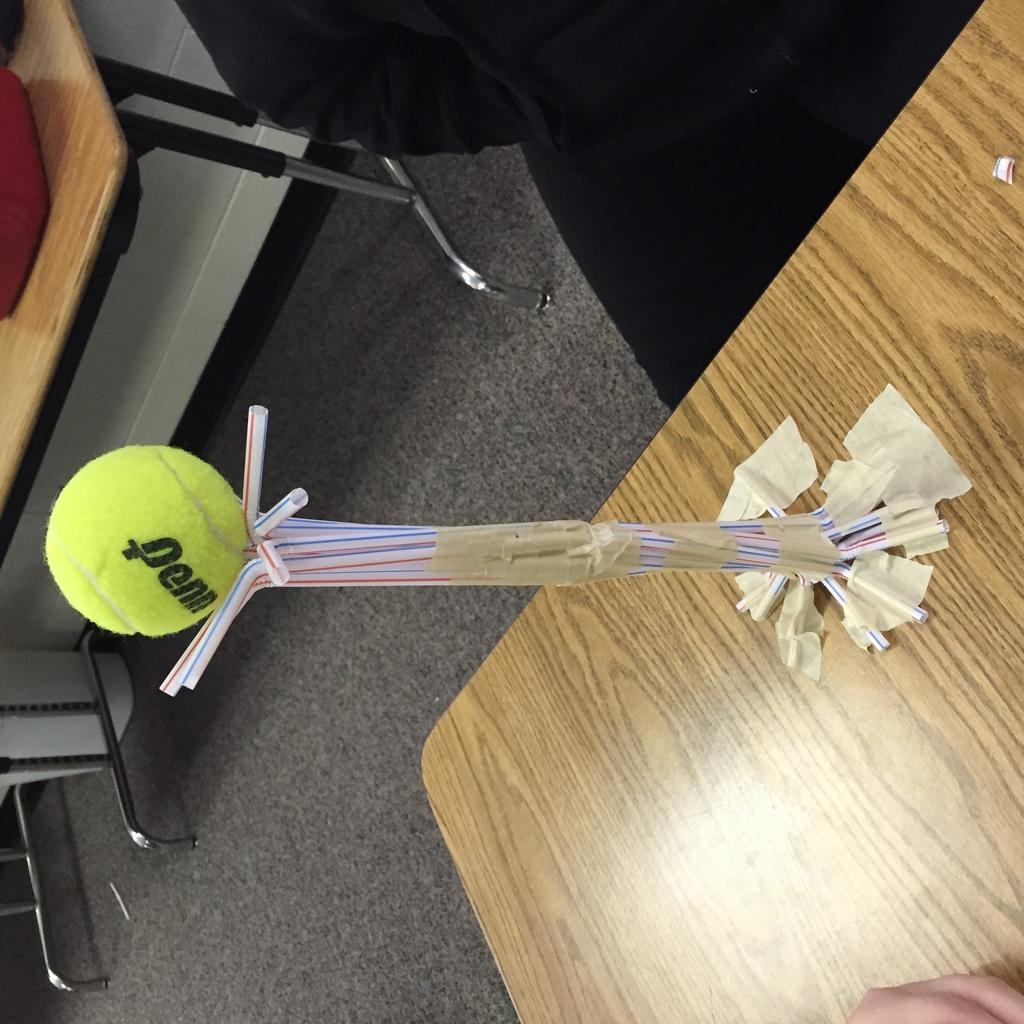What is the main surface visible in the image? The image shows a floor. What piece of furniture is present on the floor? There is a table in the image. What object is on top of the table? There is a ball on the table. What items are also present on the table? Straws and tape are visible on the table. How many cents are visible on the table in the image? There are no cents present on the table in the image. What is the tongue's role in the image? There is no tongue present in the image. 